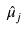Convert formula to latex. <formula><loc_0><loc_0><loc_500><loc_500>\hat { \mu } _ { j }</formula> 